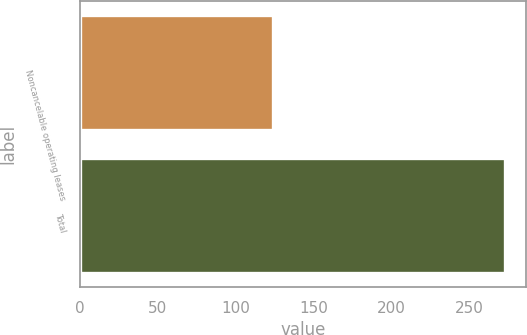<chart> <loc_0><loc_0><loc_500><loc_500><bar_chart><fcel>Noncancelable operating leases<fcel>Total<nl><fcel>124<fcel>273<nl></chart> 